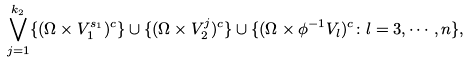<formula> <loc_0><loc_0><loc_500><loc_500>\bigvee _ { j = 1 } ^ { k _ { 2 } } \{ ( \Omega \times V _ { 1 } ^ { s _ { 1 } } ) ^ { c } \} \cup \{ ( \Omega \times V _ { 2 } ^ { j } ) ^ { c } \} \cup \{ ( \Omega \times \phi ^ { - 1 } V _ { l } ) ^ { c } \colon l = 3 , \cdots , n \} ,</formula> 